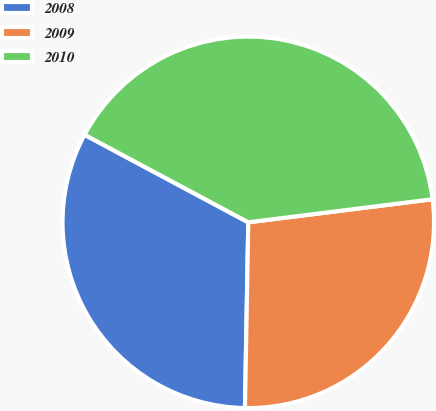Convert chart. <chart><loc_0><loc_0><loc_500><loc_500><pie_chart><fcel>2008<fcel>2009<fcel>2010<nl><fcel>32.53%<fcel>27.27%<fcel>40.2%<nl></chart> 